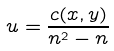Convert formula to latex. <formula><loc_0><loc_0><loc_500><loc_500>u = \frac { c ( x , y ) } { n ^ { 2 } - n }</formula> 